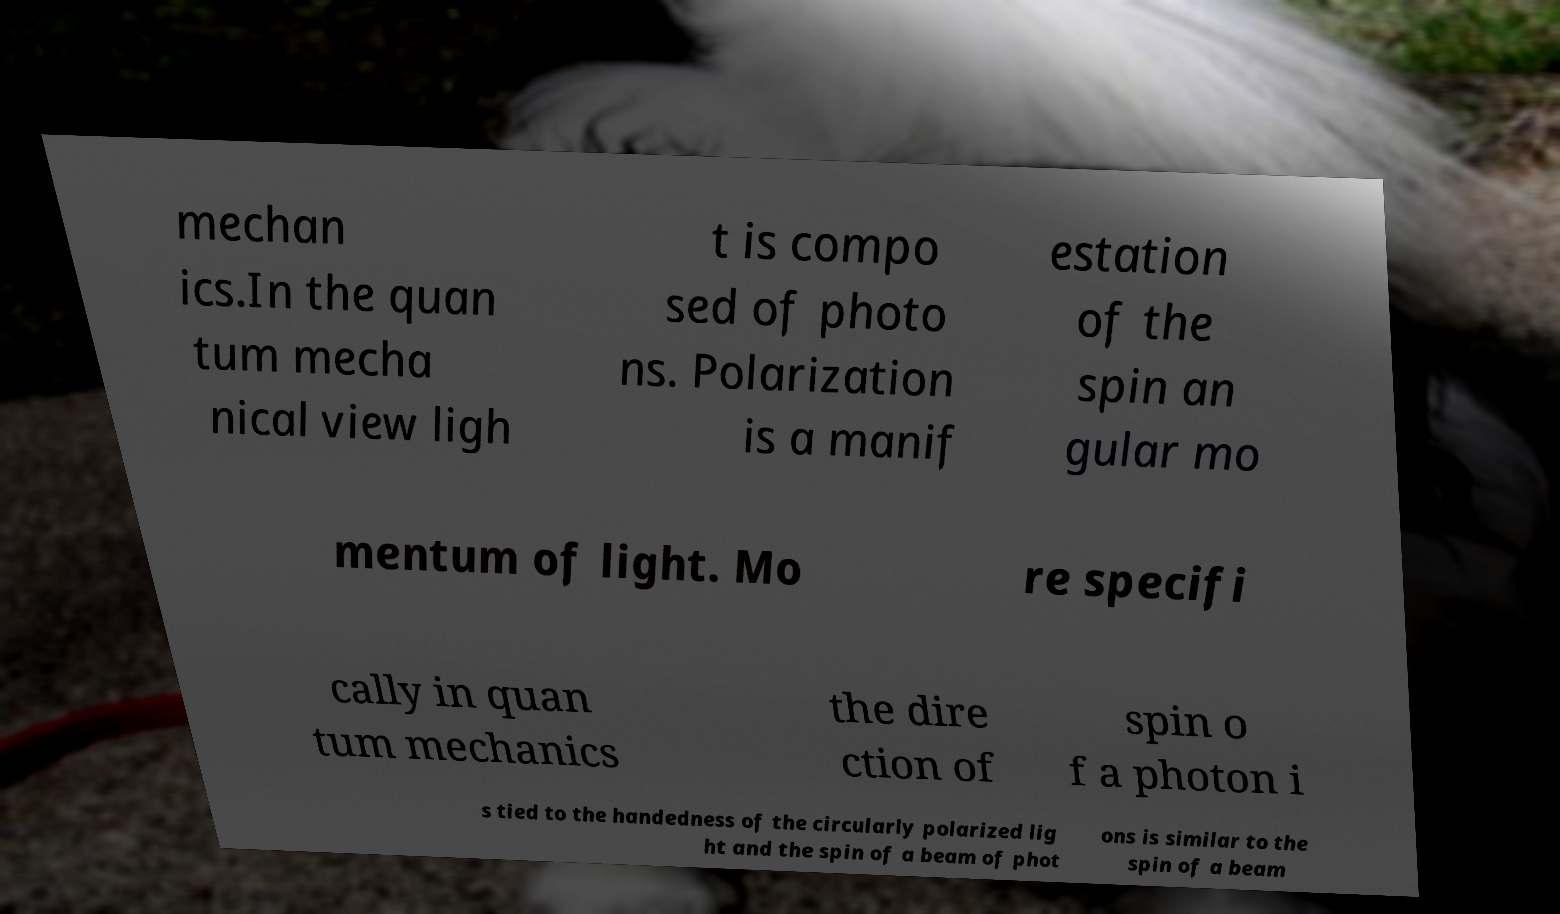Can you accurately transcribe the text from the provided image for me? mechan ics.In the quan tum mecha nical view ligh t is compo sed of photo ns. Polarization is a manif estation of the spin an gular mo mentum of light. Mo re specifi cally in quan tum mechanics the dire ction of spin o f a photon i s tied to the handedness of the circularly polarized lig ht and the spin of a beam of phot ons is similar to the spin of a beam 